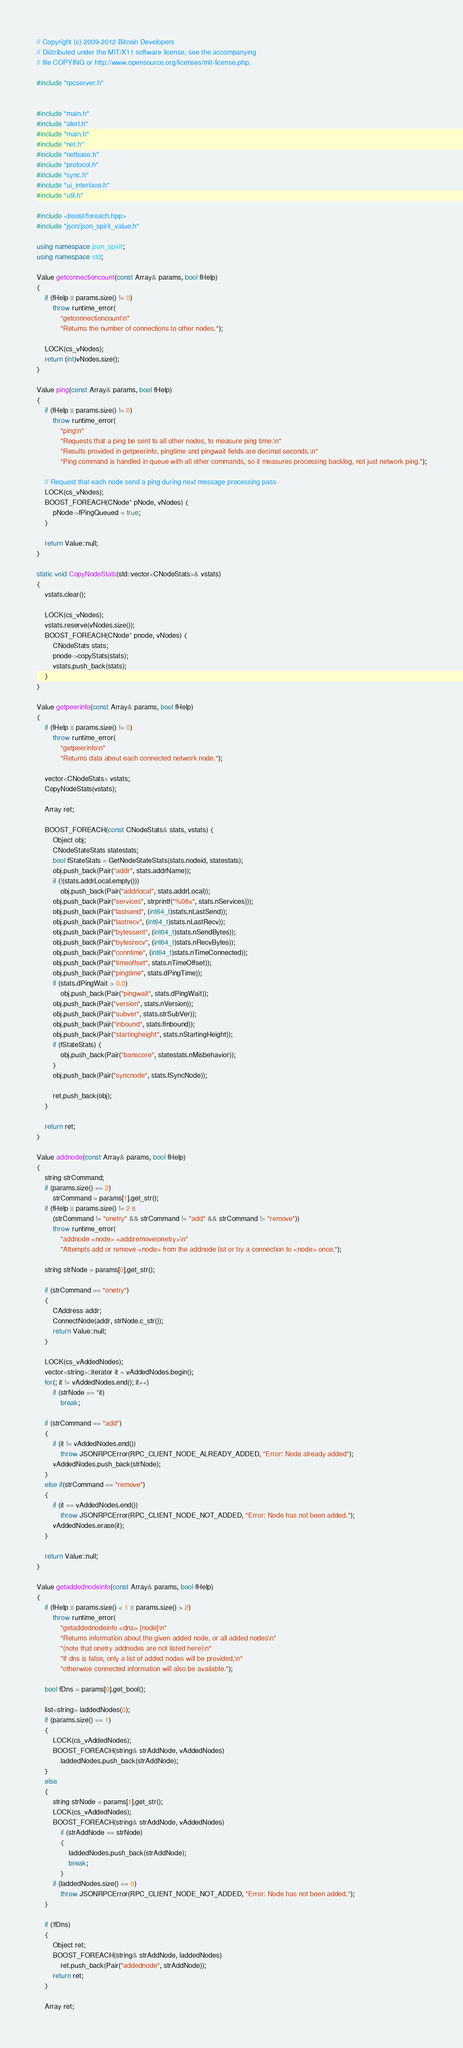<code> <loc_0><loc_0><loc_500><loc_500><_C++_>// Copyright (c) 2009-2012 Bitcoin Developers
// Distributed under the MIT/X11 software license, see the accompanying
// file COPYING or http://www.opensource.org/licenses/mit-license.php.

#include "rpcserver.h"


#include "main.h"
#include "alert.h"
#include "main.h"
#include "net.h"
#include "netbase.h"
#include "protocol.h"
#include "sync.h"
#include "ui_interface.h"
#include "util.h"

#include <boost/foreach.hpp>
#include "json/json_spirit_value.h"

using namespace json_spirit;
using namespace std;

Value getconnectioncount(const Array& params, bool fHelp)
{
    if (fHelp || params.size() != 0)
        throw runtime_error(
            "getconnectioncount\n"
            "Returns the number of connections to other nodes.");

    LOCK(cs_vNodes);
    return (int)vNodes.size();
}

Value ping(const Array& params, bool fHelp)
{
    if (fHelp || params.size() != 0)
        throw runtime_error(
            "ping\n"
            "Requests that a ping be sent to all other nodes, to measure ping time.\n"
            "Results provided in getpeerinfo, pingtime and pingwait fields are decimal seconds.\n"
            "Ping command is handled in queue with all other commands, so it measures processing backlog, not just network ping.");

    // Request that each node send a ping during next message processing pass
    LOCK(cs_vNodes);
    BOOST_FOREACH(CNode* pNode, vNodes) {
        pNode->fPingQueued = true;
    }

    return Value::null;
}

static void CopyNodeStats(std::vector<CNodeStats>& vstats)
{
    vstats.clear();

    LOCK(cs_vNodes);
    vstats.reserve(vNodes.size());
    BOOST_FOREACH(CNode* pnode, vNodes) {
        CNodeStats stats;
        pnode->copyStats(stats);
        vstats.push_back(stats);
    }
}

Value getpeerinfo(const Array& params, bool fHelp)
{
    if (fHelp || params.size() != 0)
        throw runtime_error(
            "getpeerinfo\n"
            "Returns data about each connected network node.");

    vector<CNodeStats> vstats;
    CopyNodeStats(vstats);

    Array ret;

    BOOST_FOREACH(const CNodeStats& stats, vstats) {
        Object obj;
        CNodeStateStats statestats;
        bool fStateStats = GetNodeStateStats(stats.nodeid, statestats);
        obj.push_back(Pair("addr", stats.addrName));
        if (!(stats.addrLocal.empty()))
            obj.push_back(Pair("addrlocal", stats.addrLocal));
        obj.push_back(Pair("services", strprintf("%08x", stats.nServices)));
        obj.push_back(Pair("lastsend", (int64_t)stats.nLastSend));
        obj.push_back(Pair("lastrecv", (int64_t)stats.nLastRecv));
        obj.push_back(Pair("bytessent", (int64_t)stats.nSendBytes));
        obj.push_back(Pair("bytesrecv", (int64_t)stats.nRecvBytes));
        obj.push_back(Pair("conntime", (int64_t)stats.nTimeConnected));
        obj.push_back(Pair("timeoffset", stats.nTimeOffset));
        obj.push_back(Pair("pingtime", stats.dPingTime));
        if (stats.dPingWait > 0.0)
            obj.push_back(Pair("pingwait", stats.dPingWait));
        obj.push_back(Pair("version", stats.nVersion));
        obj.push_back(Pair("subver", stats.strSubVer));
        obj.push_back(Pair("inbound", stats.fInbound));
        obj.push_back(Pair("startingheight", stats.nStartingHeight));
        if (fStateStats) {
            obj.push_back(Pair("banscore", statestats.nMisbehavior));
        }
        obj.push_back(Pair("syncnode", stats.fSyncNode));

        ret.push_back(obj);
    }

    return ret;
}

Value addnode(const Array& params, bool fHelp)
{
    string strCommand;
    if (params.size() == 2)
        strCommand = params[1].get_str();
    if (fHelp || params.size() != 2 ||
        (strCommand != "onetry" && strCommand != "add" && strCommand != "remove"))
        throw runtime_error(
            "addnode <node> <add|remove|onetry>\n"
            "Attempts add or remove <node> from the addnode list or try a connection to <node> once.");

    string strNode = params[0].get_str();

    if (strCommand == "onetry")
    {
        CAddress addr;
        ConnectNode(addr, strNode.c_str());
        return Value::null;
    }

    LOCK(cs_vAddedNodes);
    vector<string>::iterator it = vAddedNodes.begin();
    for(; it != vAddedNodes.end(); it++)
        if (strNode == *it)
            break;

    if (strCommand == "add")
    {
        if (it != vAddedNodes.end())
            throw JSONRPCError(RPC_CLIENT_NODE_ALREADY_ADDED, "Error: Node already added");
        vAddedNodes.push_back(strNode);
    }
    else if(strCommand == "remove")
    {
        if (it == vAddedNodes.end())
            throw JSONRPCError(RPC_CLIENT_NODE_NOT_ADDED, "Error: Node has not been added.");
        vAddedNodes.erase(it);
    }

    return Value::null;
}

Value getaddednodeinfo(const Array& params, bool fHelp)
{
    if (fHelp || params.size() < 1 || params.size() > 2)
        throw runtime_error(
            "getaddednodeinfo <dns> [node]\n"
            "Returns information about the given added node, or all added nodes\n"
            "(note that onetry addnodes are not listed here)\n"
            "If dns is false, only a list of added nodes will be provided,\n"
            "otherwise connected information will also be available.");

    bool fDns = params[0].get_bool();

    list<string> laddedNodes(0);
    if (params.size() == 1)
    {
        LOCK(cs_vAddedNodes);
        BOOST_FOREACH(string& strAddNode, vAddedNodes)
            laddedNodes.push_back(strAddNode);
    }
    else
    {
        string strNode = params[1].get_str();
        LOCK(cs_vAddedNodes);
        BOOST_FOREACH(string& strAddNode, vAddedNodes)
            if (strAddNode == strNode)
            {
                laddedNodes.push_back(strAddNode);
                break;
            }
        if (laddedNodes.size() == 0)
            throw JSONRPCError(RPC_CLIENT_NODE_NOT_ADDED, "Error: Node has not been added.");
    }

    if (!fDns)
    {
        Object ret;
        BOOST_FOREACH(string& strAddNode, laddedNodes)
            ret.push_back(Pair("addednode", strAddNode));
        return ret;
    }

    Array ret;
</code> 